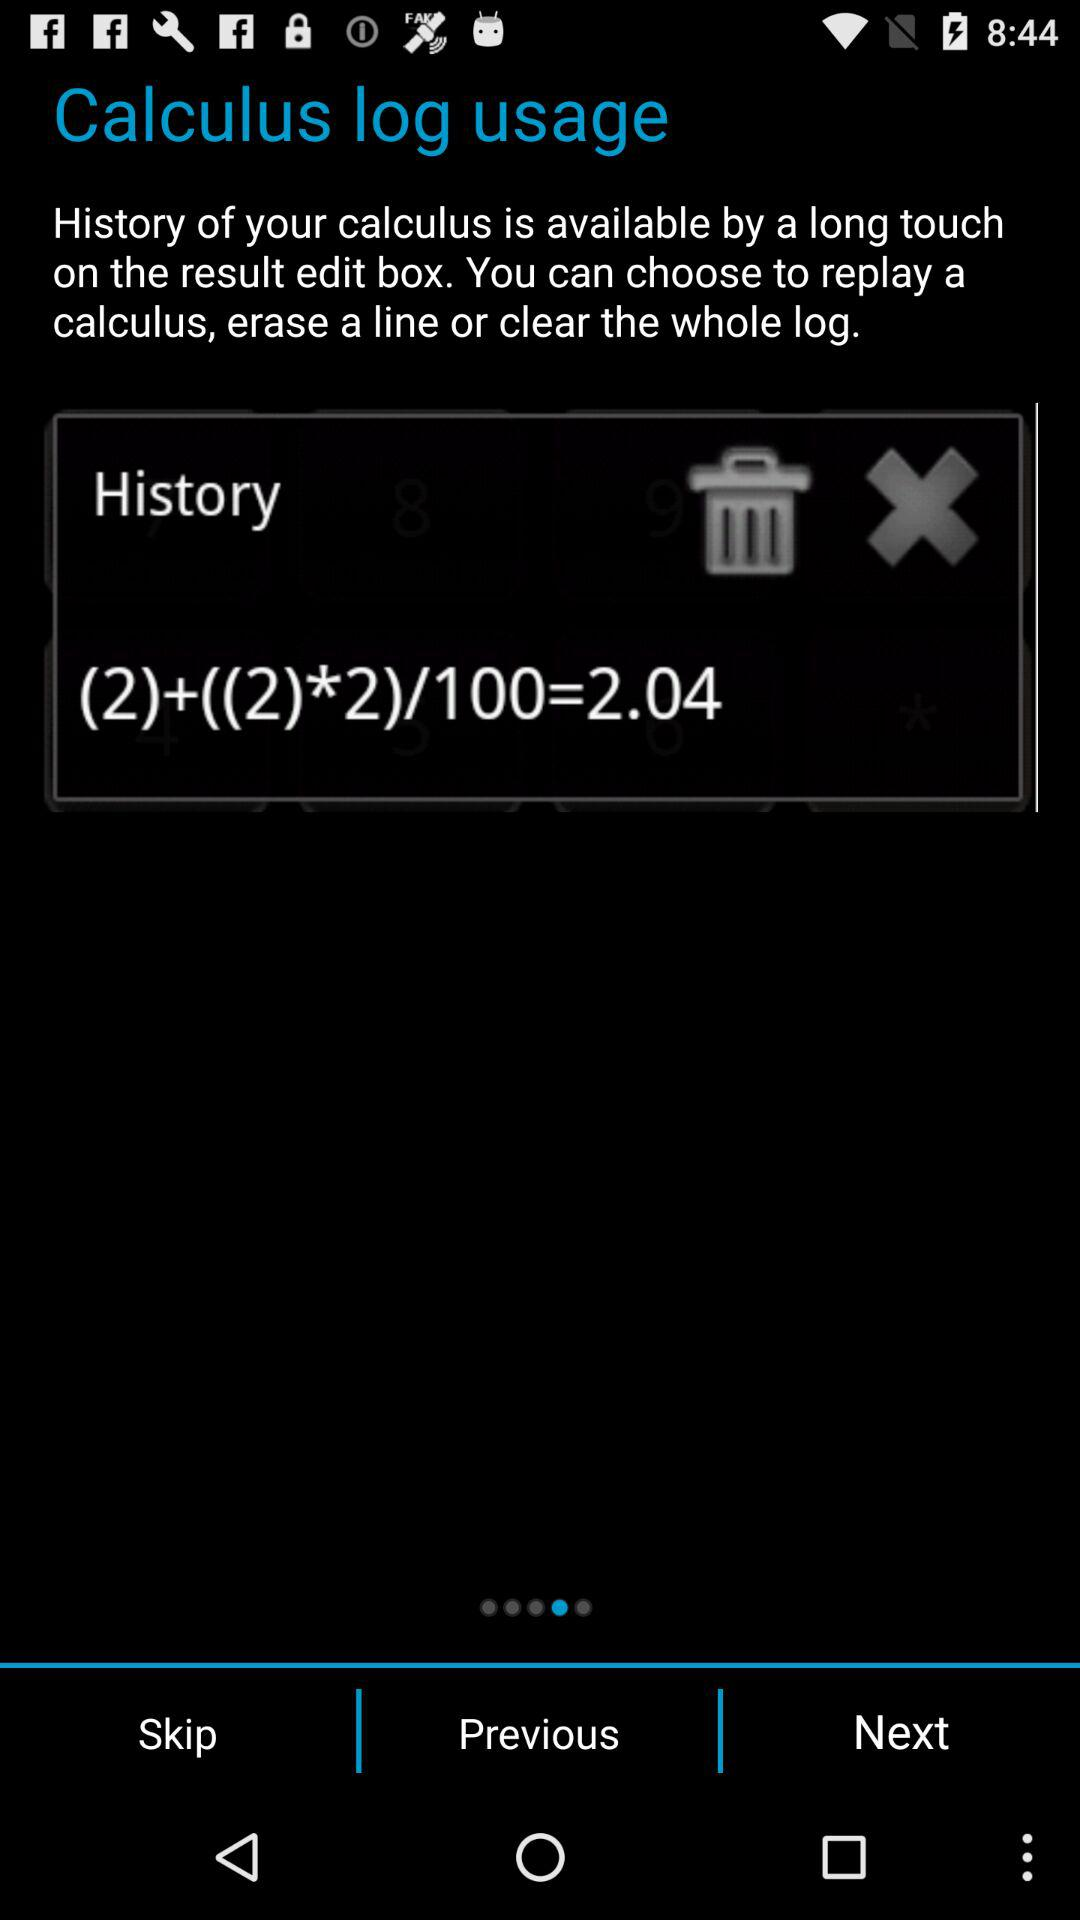What is the log history in the "Calculus" application? The log history is "(2)+((2)*2)/100=2.04". 